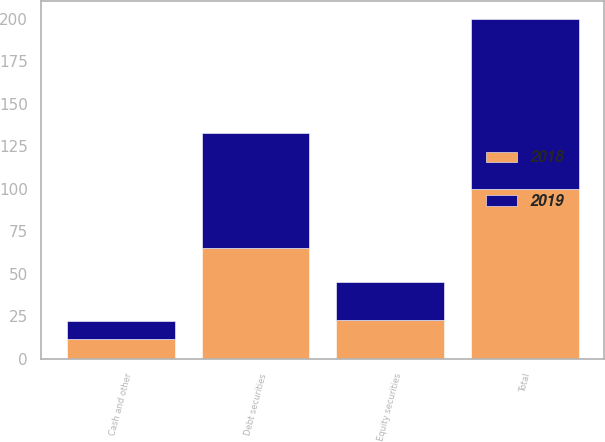Convert chart. <chart><loc_0><loc_0><loc_500><loc_500><stacked_bar_chart><ecel><fcel>Equity securities<fcel>Debt securities<fcel>Cash and other<fcel>Total<nl><fcel>2019<fcel>22<fcel>68<fcel>10<fcel>100<nl><fcel>2018<fcel>23<fcel>65<fcel>12<fcel>100<nl></chart> 